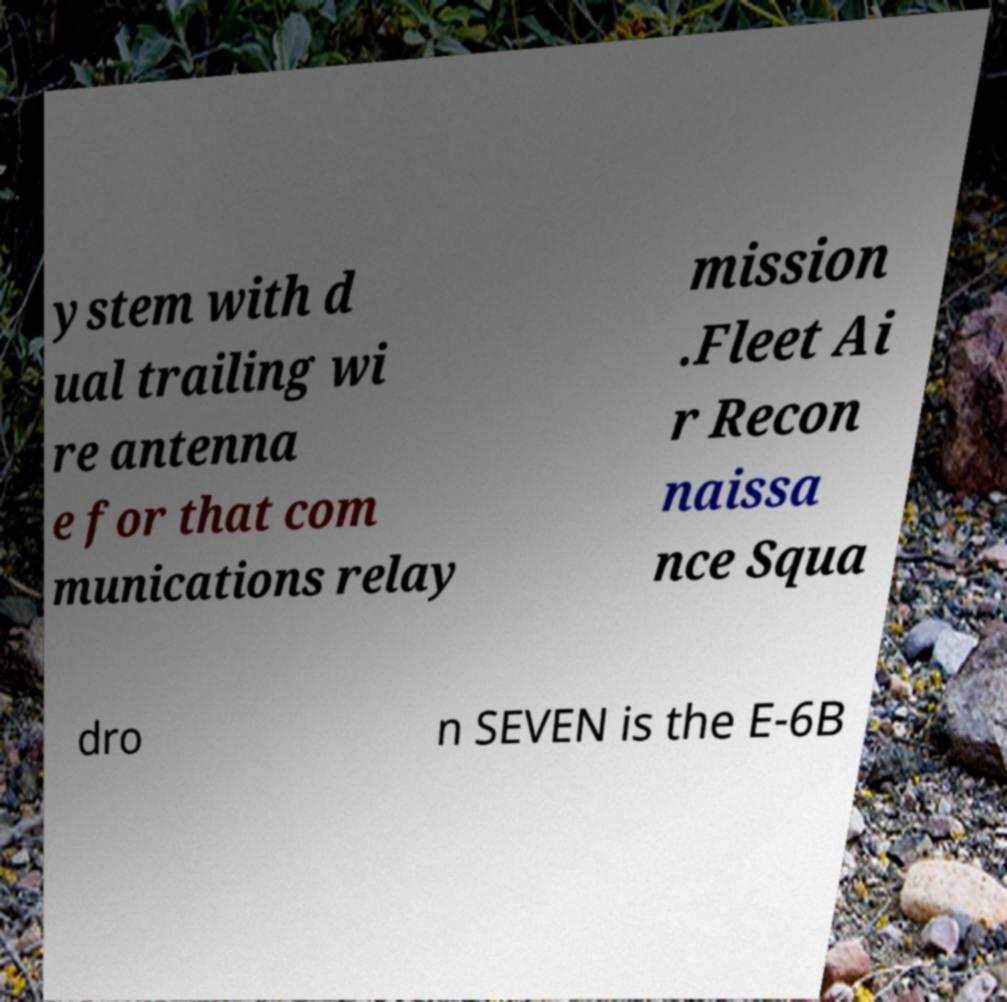Could you extract and type out the text from this image? ystem with d ual trailing wi re antenna e for that com munications relay mission .Fleet Ai r Recon naissa nce Squa dro n SEVEN is the E-6B 